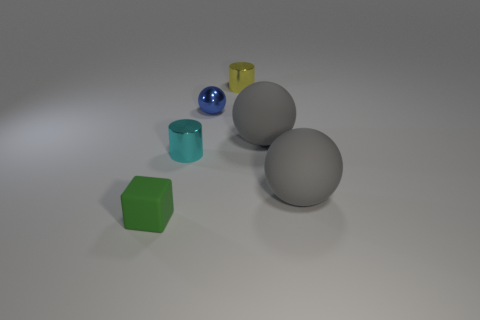There is a sphere on the left side of the yellow shiny cylinder; is its color the same as the tiny metallic cylinder that is in front of the small ball?
Provide a succinct answer. No. How many other things are there of the same material as the yellow cylinder?
Your answer should be compact. 2. There is a object that is both on the left side of the yellow cylinder and in front of the tiny cyan metallic object; what shape is it?
Keep it short and to the point. Cube. Does the small rubber object have the same color as the small object on the right side of the blue metal thing?
Your response must be concise. No. Is the size of the thing behind the blue metallic object the same as the tiny blue object?
Offer a terse response. Yes. There is a small cyan thing that is the same shape as the yellow thing; what material is it?
Offer a very short reply. Metal. Do the tiny cyan shiny object and the tiny yellow shiny thing have the same shape?
Provide a short and direct response. Yes. What number of tiny yellow shiny cylinders are behind the small cylinder to the right of the blue sphere?
Ensure brevity in your answer.  0. What is the shape of the blue thing that is made of the same material as the tiny yellow cylinder?
Offer a terse response. Sphere. How many cyan objects are either metal things or tiny matte objects?
Offer a very short reply. 1. 